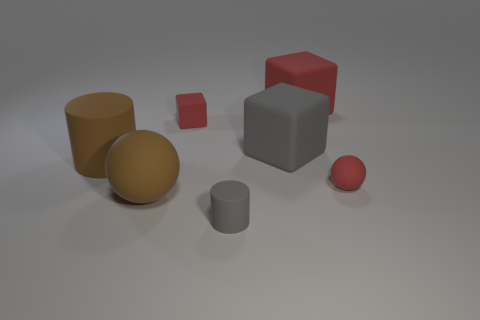Add 2 big cylinders. How many objects exist? 9 Subtract all cylinders. How many objects are left? 5 Subtract 0 blue blocks. How many objects are left? 7 Subtract all large red matte things. Subtract all big gray matte balls. How many objects are left? 6 Add 4 big brown matte cylinders. How many big brown matte cylinders are left? 5 Add 2 small cylinders. How many small cylinders exist? 3 